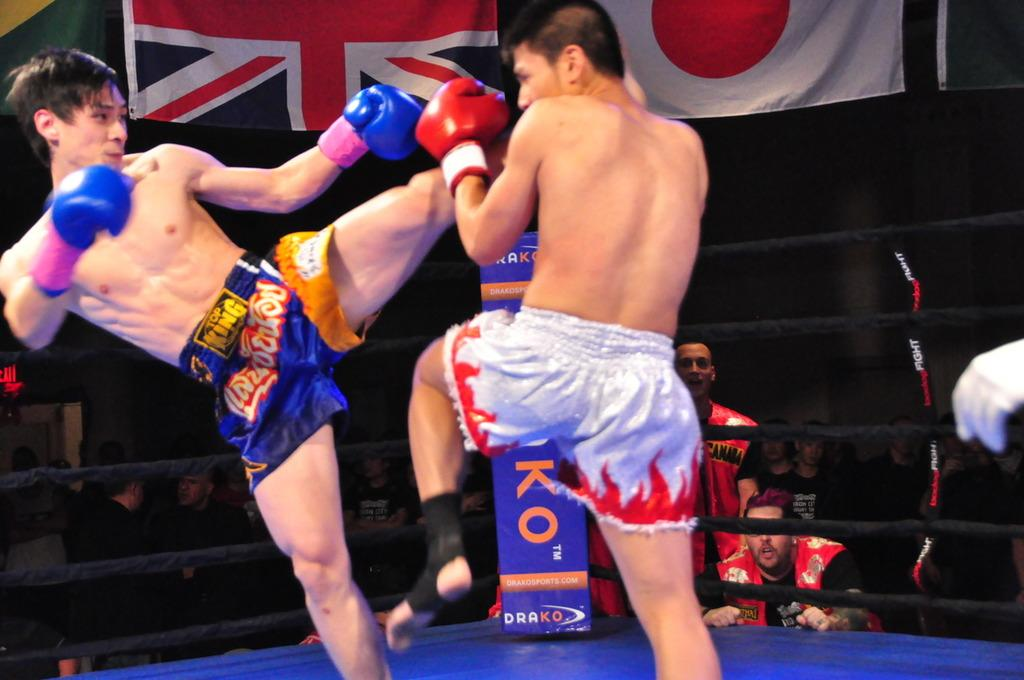What are the two persons in the image doing? The two persons in the image are doing boxing. What is located behind the boxers? There is a fencing behind the boxers. Who else is present in the image besides the boxers? There are people standing and watching behind the fencing. What can be seen at the top of the image? There are flags visible at the top of the image. What type of sand can be seen on the boxing ring in the image? There is no sand visible on the boxing ring in the image; it appears to be a typical boxing setup with a fencing and spectators. 